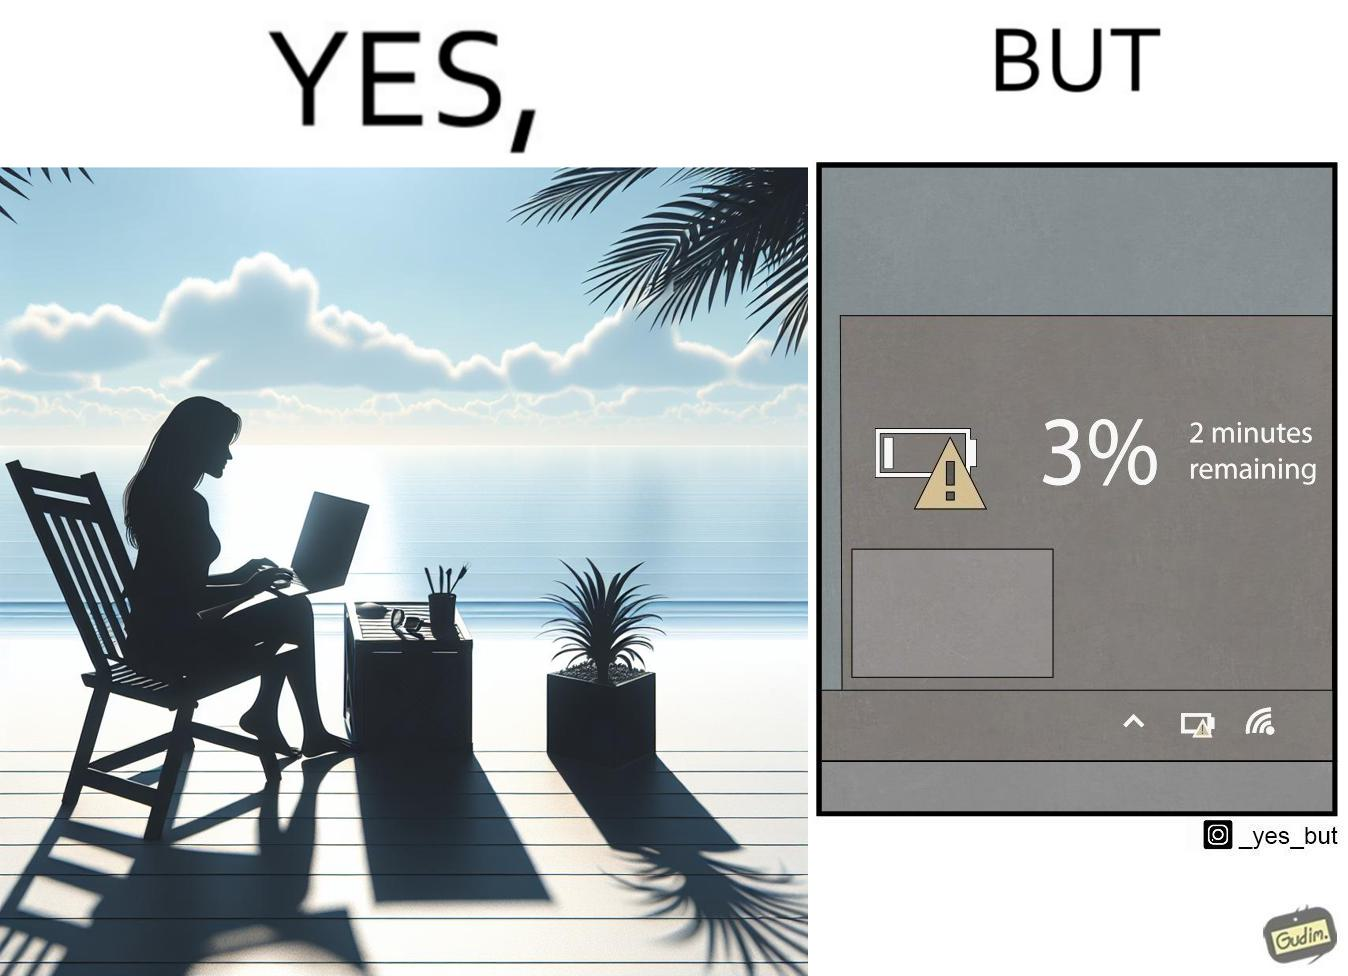What is the satirical meaning behind this image? The image is ironical, as a person is working on a laptop in a beach, which looks like a soothing and calm environment to work. However, the laptop is about to get discharged, and there is probably no electric supply to keep the laptop open while working on the beach, turning the situation into an inconvenience. 